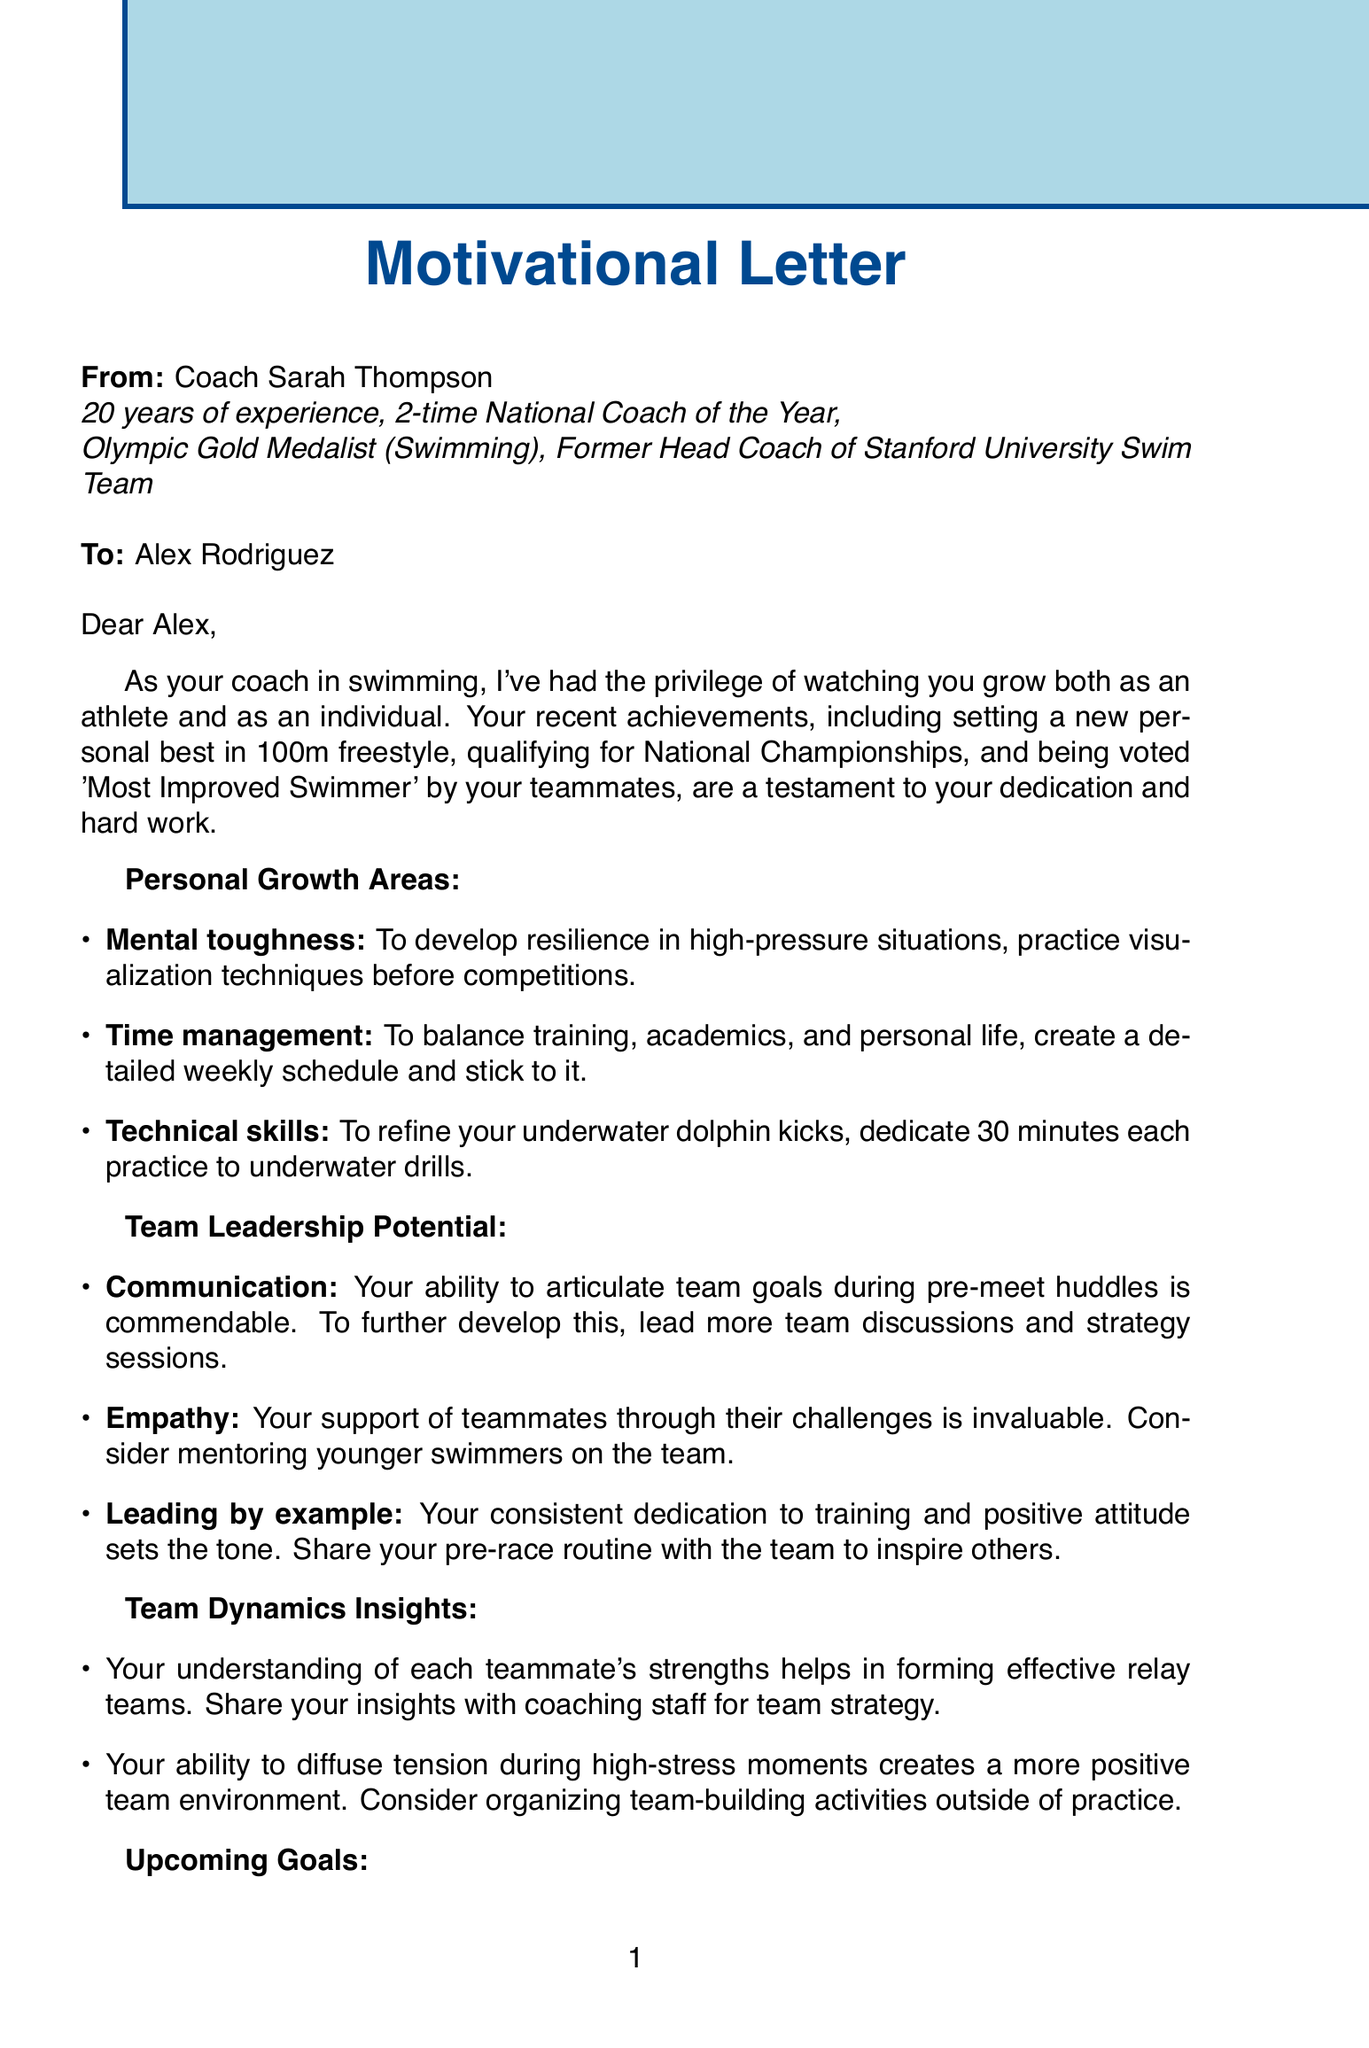What is the coach's name? The coach's name is mentioned at the beginning of the letter.
Answer: Coach Sarah Thompson How many years of experience does the coach have? The document states the number of years of experience for Coach Sarah Thompson.
Answer: 20 What area of personal growth involves creating a weekly schedule? This area is described in the personal growth section of the document.
Answer: Time management What is one of Alex Rodriguez's recent achievements? The letter lists several achievements under a specific section.
Answer: Set new personal best in 100m freestyle What quality is highlighted regarding Alex's ability to support teammates? This quality is mentioned in the team leadership potential section.
Answer: Empathy What is one of Alex's upcoming goals? The document lists goals Alex wants to achieve in the near future.
Answer: Secure a spot on the Olympic team What type of activities does the document suggest organizing to improve team dynamics? This is noted under team dynamics insights for building a positive environment.
Answer: Team-building activities What is the inspirational quote shared in the letter? The motivational statement in the document emphasizes determination.
Answer: The difference between the impossible and the possible lies in a person's determination 